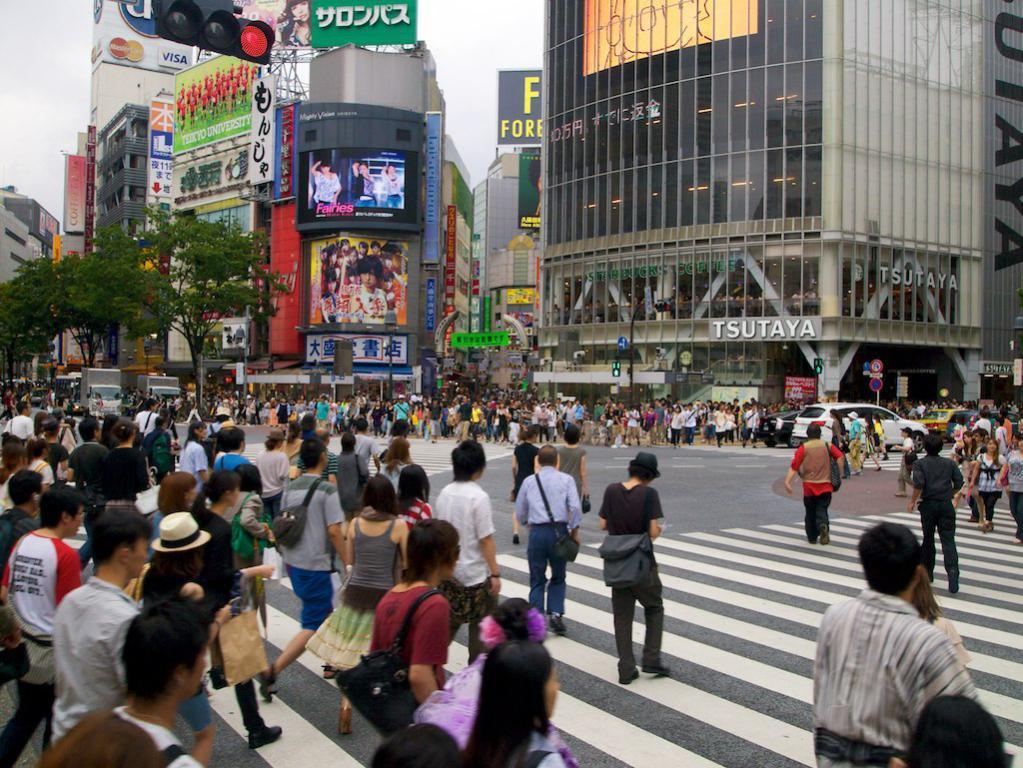How would you summarize this image in a sentence or two? In this image we can see a group of persons. Behind the persons we can see buildings and vehicles. On the buildings we can see advertising boards with text and images. At the top we can see traffic lights and the sky. On the left side, we can see the trees and vehicles. 